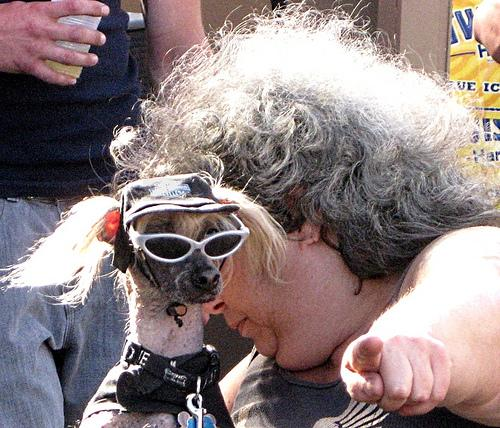Concisely describe the appearance of the subjects in the image and what they are doing. An elderly woman with gray hair points her finger, standing next to a dog wearing fashionable sunglasses, a hat, and an embellished collar. Identify the two main subjects in the image and describe their key features. The woman with unruly gray hair and a gray tank top is pointing her finger, and the dog, wearing sunglasses, a hat, and a decorated collar, sits beside her. Describe the relationship between the subjects in the image. A woman and her canine companion captivate attention as she directs with a point, and the dog exudes style in sunglasses, a hat, and a decorative collar. Provide a short description of the main focus of the image. A dog is wearing sunglasses, a black hat, and a collar with various tags and designs, sitting beside a woman with gray hair. Mention the central figures of the photo, including the actions and accessories. The woman, pointing her finger and sporting gray hair, is paired with a well-accessorized dog in sunglasses, a black hat, and a decorated collar. Use expressive language to describe the scene in the image. An aging woman with wild gray locks directs our attention with a pointed finger, while her stylish canine companion dons sunglasses, a black hat, and a fancy collar nearby. Explain the most notable elements in the image. The image features a dog wearing sunglasses, a black hat, and a collar with multiple tags, as well as a woman in a gray tank top with gray hair, pointing her finger. Write a brief summary of the scene in the image. A gray-haired woman in a tank top points her finger while standing next to a stylish dog adorned with sunglasses, a hat, and a decorated collar. State the main characteristics of the image, focusing on fashion and accessories. The dog in the image wears white sunglasses, a black hat, and a collar with tags while a gray-haired woman wears a gray tank top and points her finger. Highlight the main subjects in the image and describe the clothes and accessories they wear. The gray-haired woman in a gray tank top stands pointing her finger, as her dog wears fashionable sunglasses, a black hat, and a unique collar. 